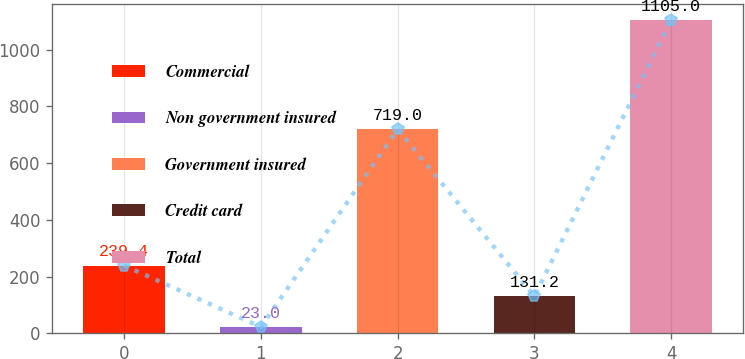<chart> <loc_0><loc_0><loc_500><loc_500><bar_chart><fcel>Commercial<fcel>Non government insured<fcel>Government insured<fcel>Credit card<fcel>Total<nl><fcel>239.4<fcel>23<fcel>719<fcel>131.2<fcel>1105<nl></chart> 